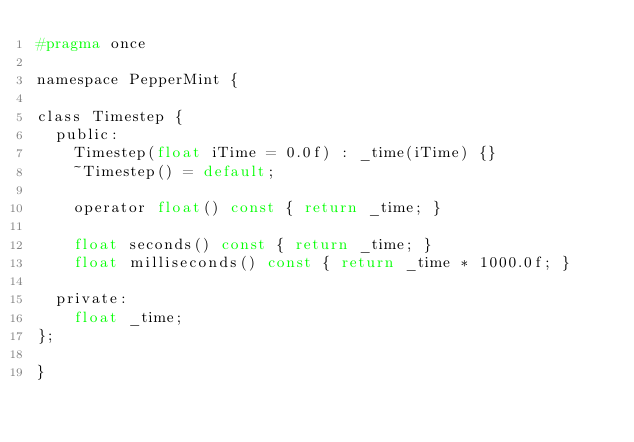<code> <loc_0><loc_0><loc_500><loc_500><_C_>#pragma once

namespace PepperMint {

class Timestep {
  public:
    Timestep(float iTime = 0.0f) : _time(iTime) {}
    ~Timestep() = default;

    operator float() const { return _time; }

    float seconds() const { return _time; }
    float milliseconds() const { return _time * 1000.0f; }

  private:
    float _time;
};

}
</code> 